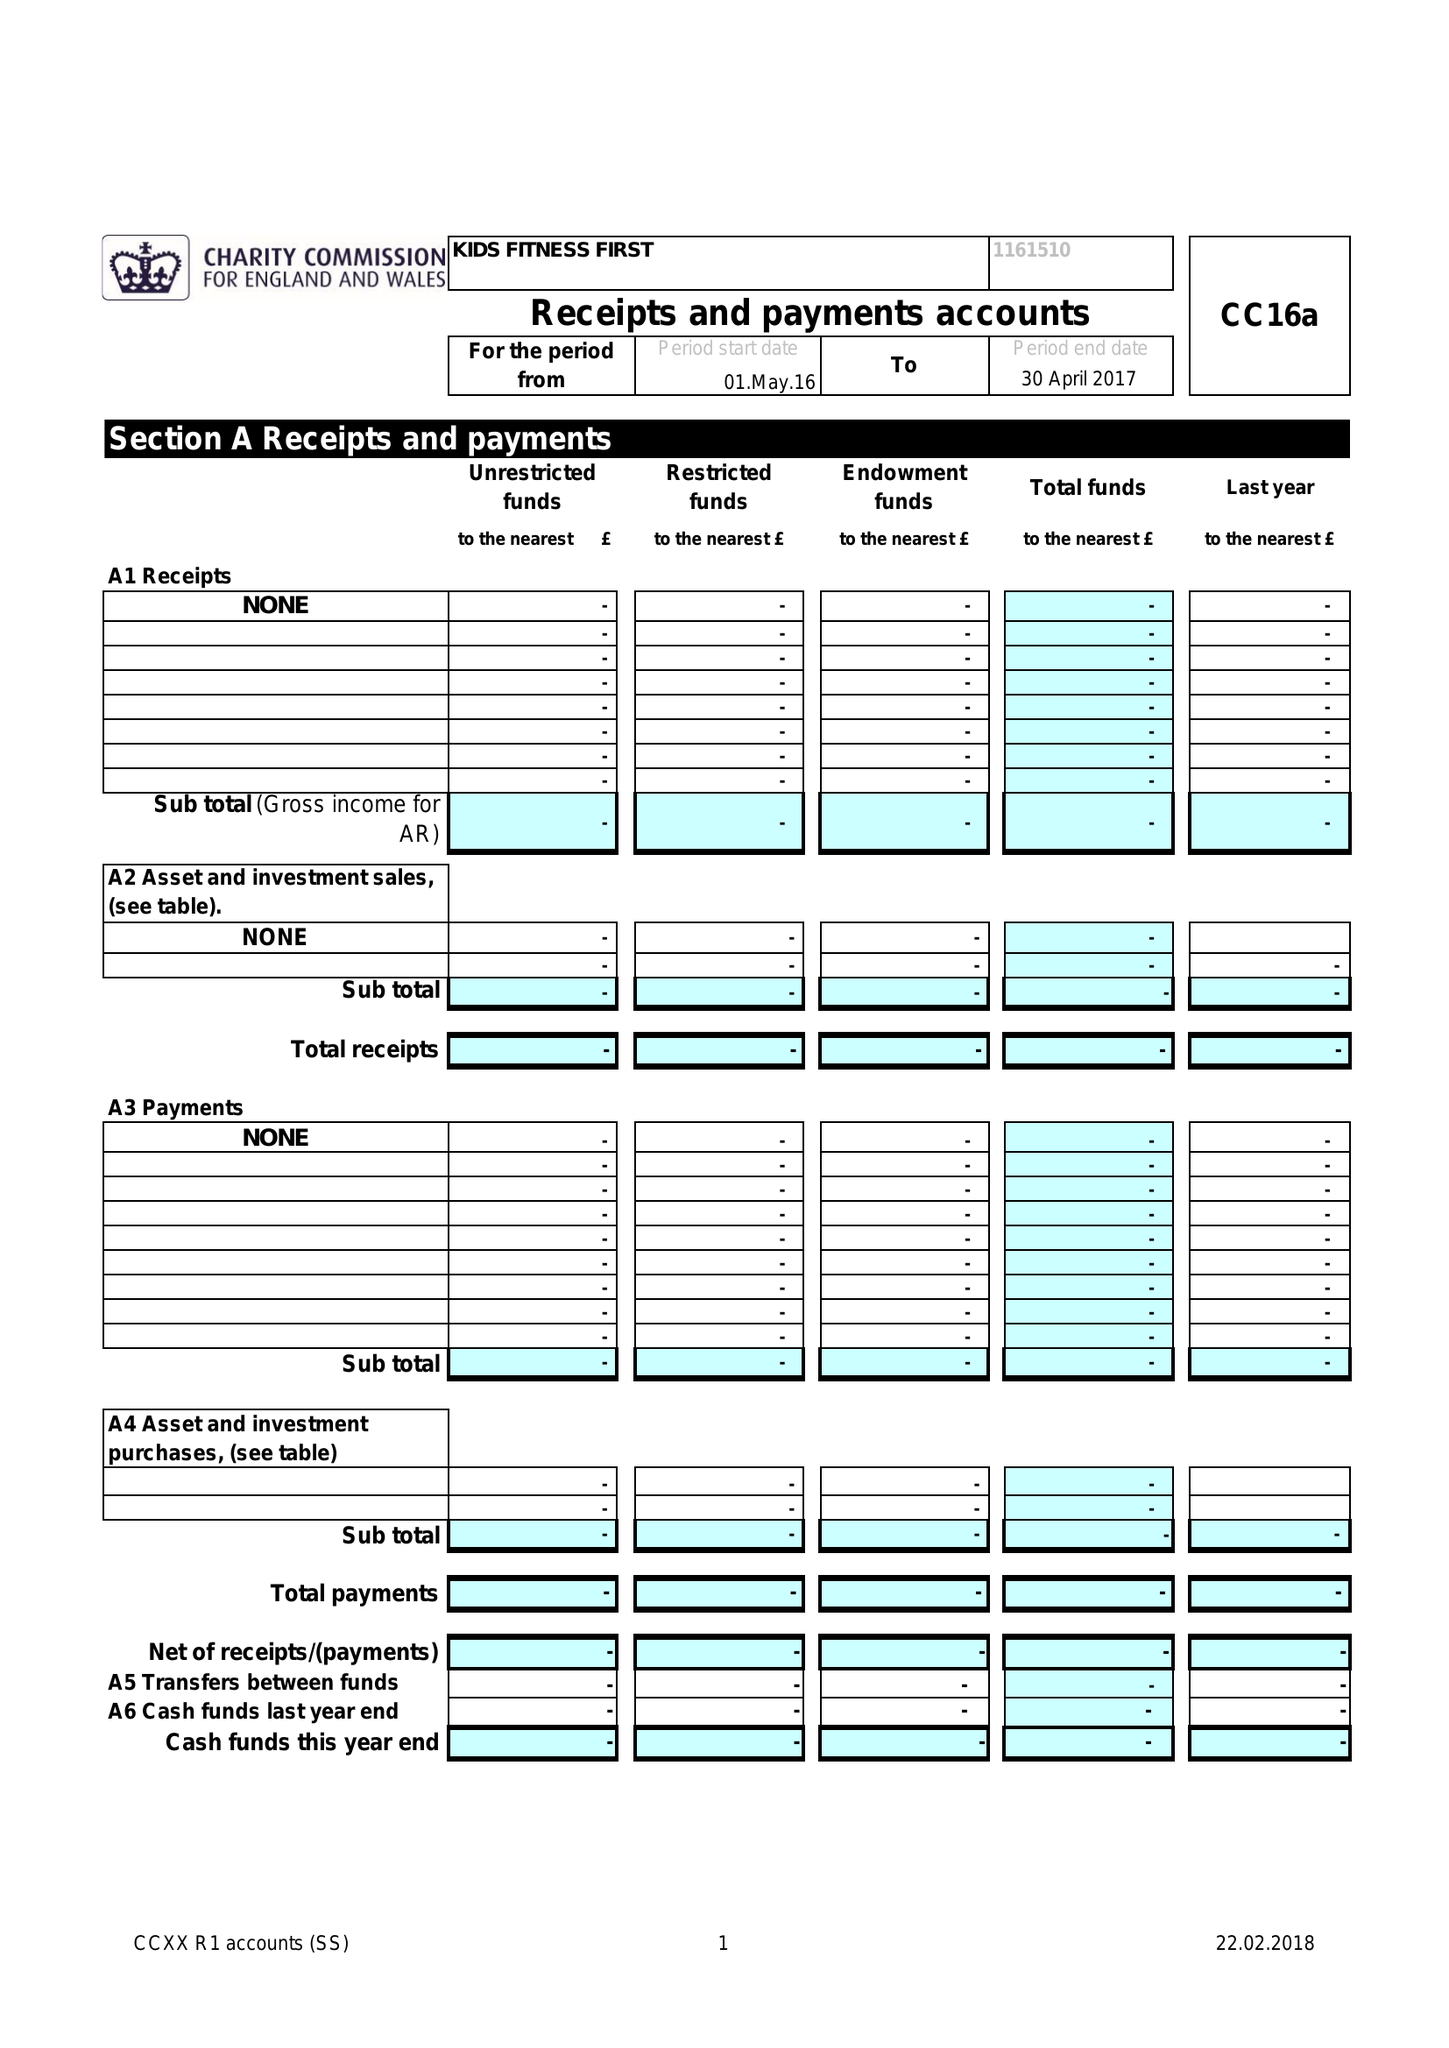What is the value for the report_date?
Answer the question using a single word or phrase. 2017-04-30 